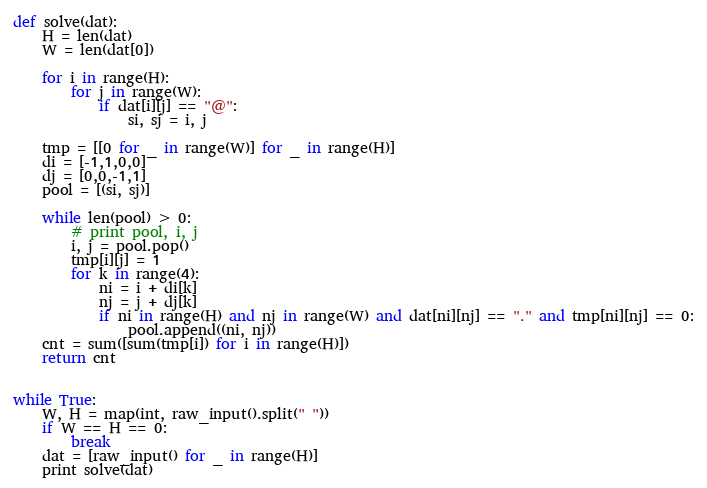Convert code to text. <code><loc_0><loc_0><loc_500><loc_500><_Python_>def solve(dat):
    H = len(dat)
    W = len(dat[0])

    for i in range(H):
        for j in range(W):
            if dat[i][j] == "@":
                si, sj = i, j

    tmp = [[0 for _ in range(W)] for _ in range(H)]
    di = [-1,1,0,0]
    dj = [0,0,-1,1]
    pool = [(si, sj)]

    while len(pool) > 0:
        # print pool, i, j
        i, j = pool.pop()
        tmp[i][j] = 1
        for k in range(4):
            ni = i + di[k]
            nj = j + dj[k]
            if ni in range(H) and nj in range(W) and dat[ni][nj] == "." and tmp[ni][nj] == 0:
                pool.append((ni, nj))
    cnt = sum([sum(tmp[i]) for i in range(H)])
    return cnt


while True:
    W, H = map(int, raw_input().split(" "))
    if W == H == 0:
        break
    dat = [raw_input() for _ in range(H)]
    print solve(dat)
</code> 